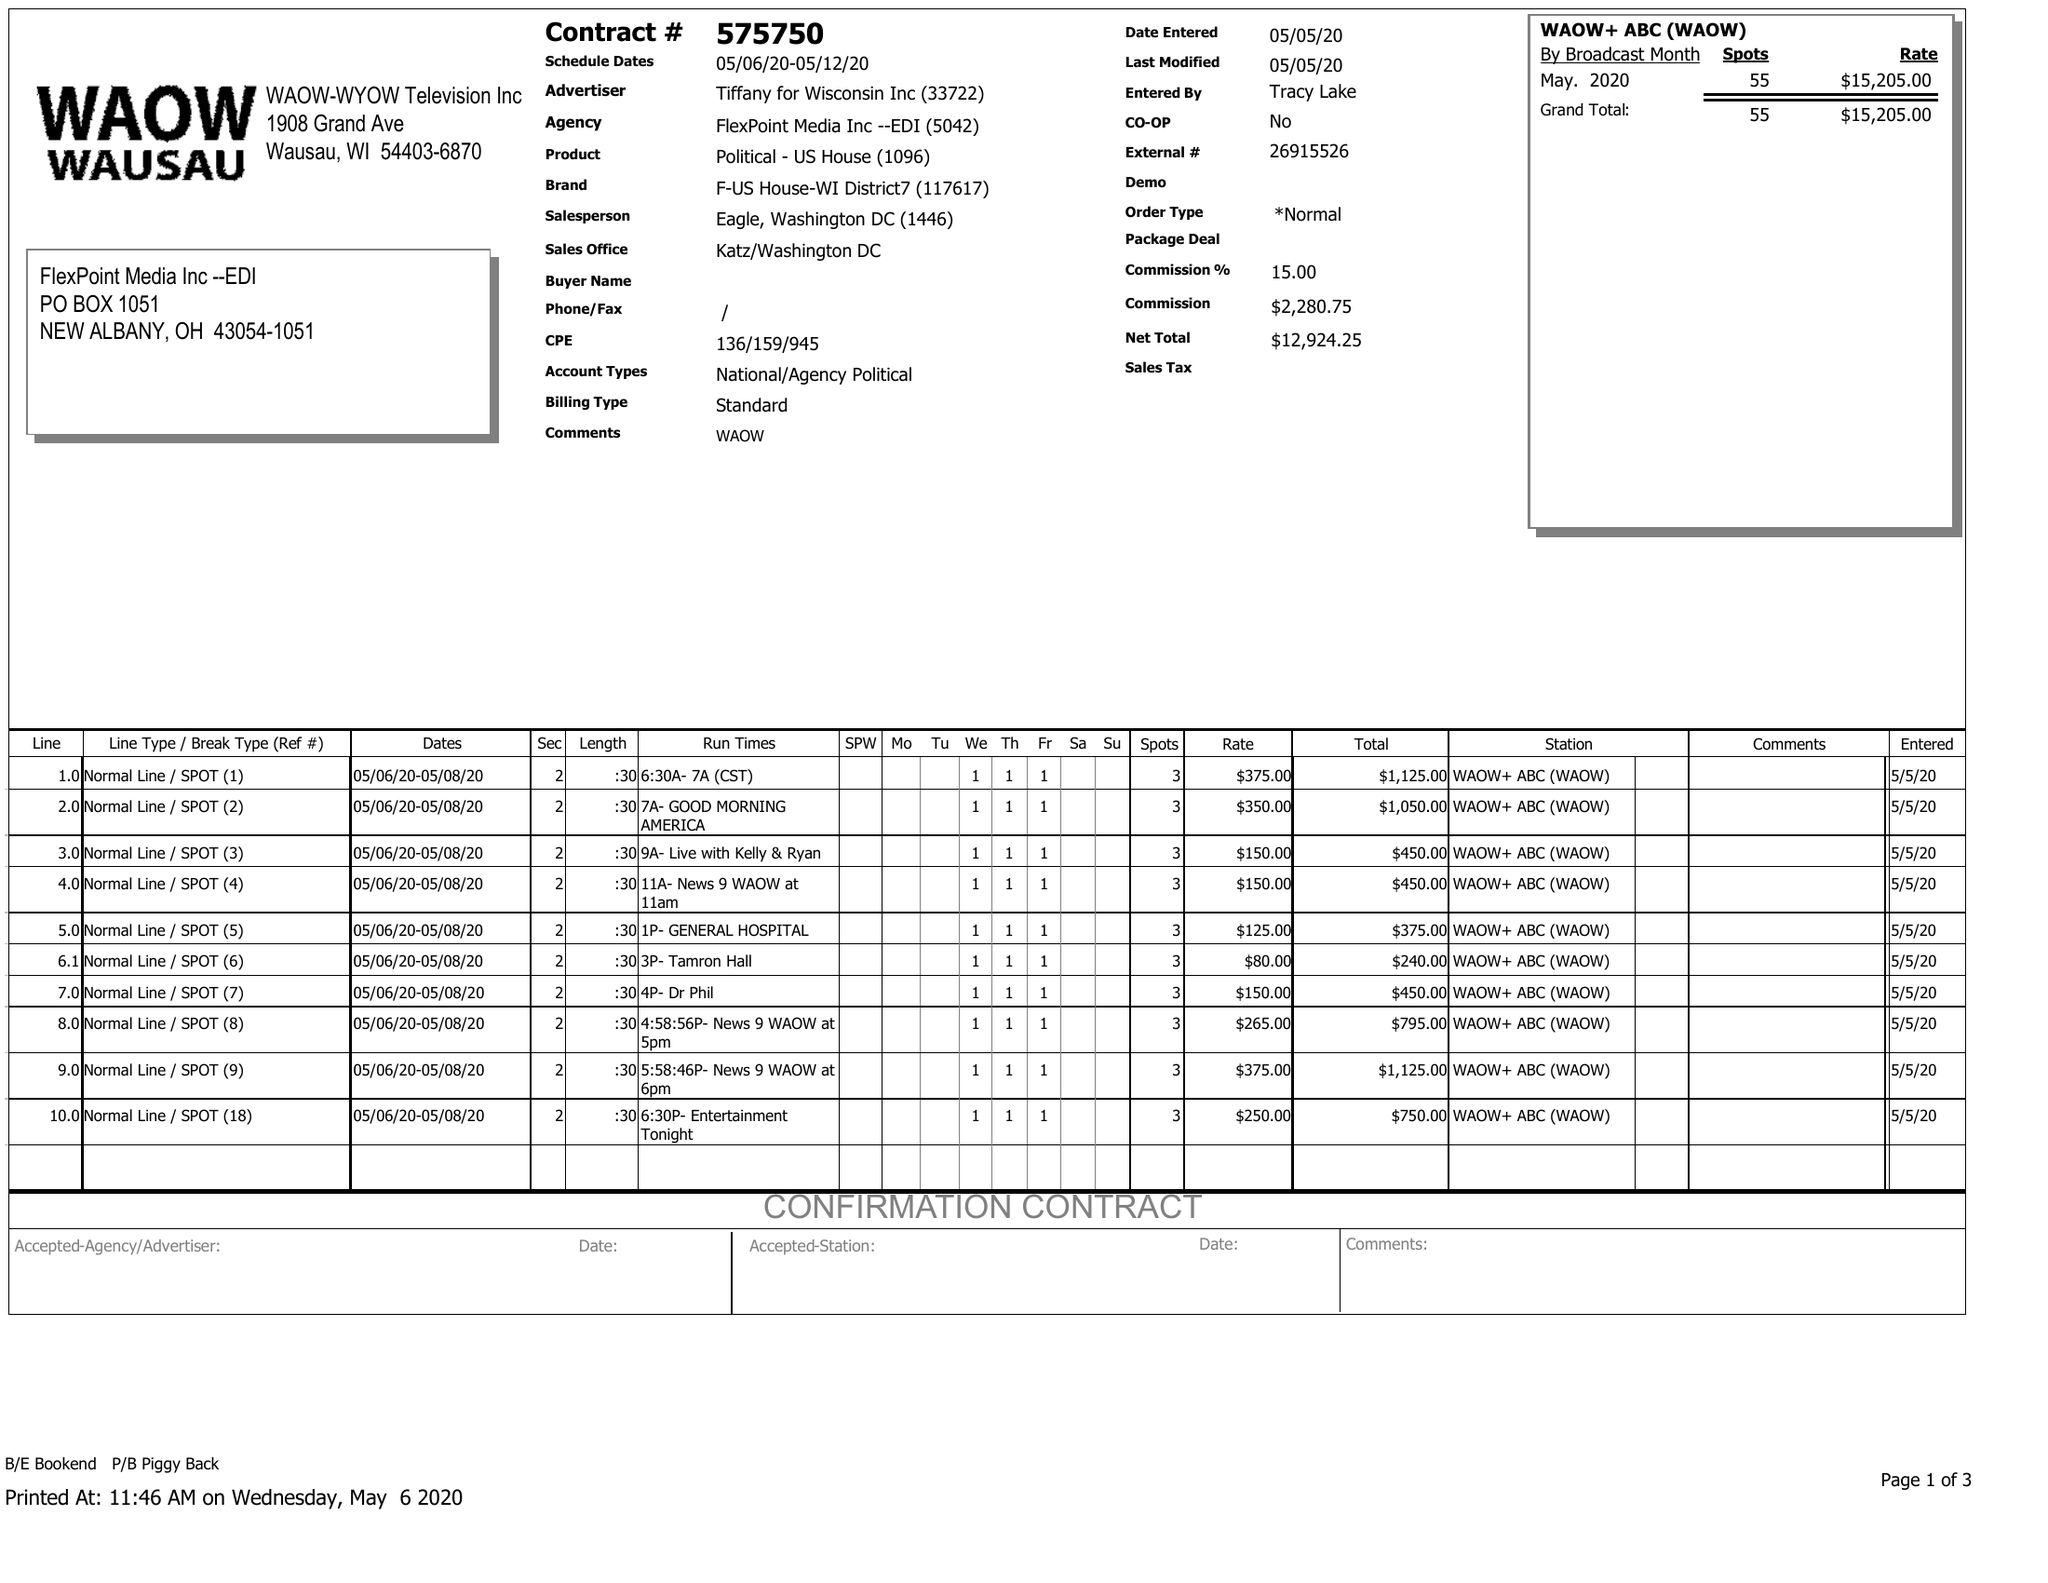What is the value for the advertiser?
Answer the question using a single word or phrase. TIFFANY FOR WISCONSIN INC 